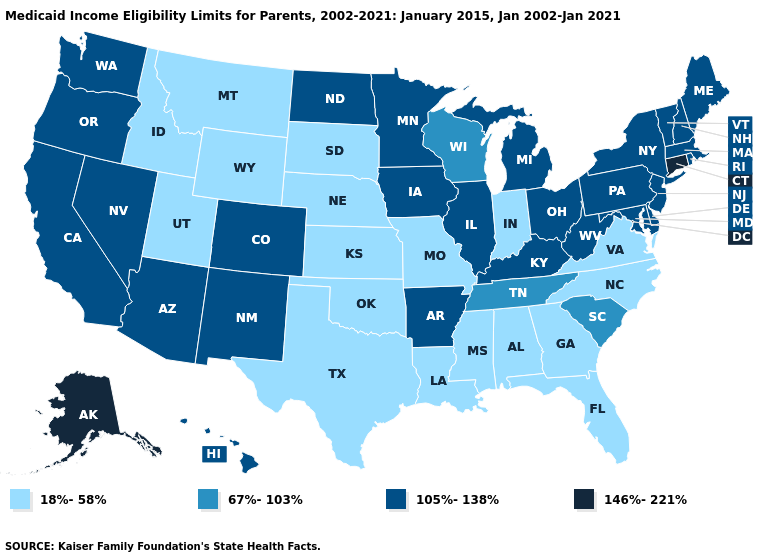Is the legend a continuous bar?
Give a very brief answer. No. Which states have the highest value in the USA?
Keep it brief. Alaska, Connecticut. Name the states that have a value in the range 146%-221%?
Be succinct. Alaska, Connecticut. Name the states that have a value in the range 18%-58%?
Write a very short answer. Alabama, Florida, Georgia, Idaho, Indiana, Kansas, Louisiana, Mississippi, Missouri, Montana, Nebraska, North Carolina, Oklahoma, South Dakota, Texas, Utah, Virginia, Wyoming. What is the value of New Hampshire?
Short answer required. 105%-138%. Name the states that have a value in the range 146%-221%?
Concise answer only. Alaska, Connecticut. Does Alaska have the highest value in the West?
Be succinct. Yes. What is the lowest value in the USA?
Write a very short answer. 18%-58%. What is the value of Missouri?
Concise answer only. 18%-58%. Does North Carolina have a higher value than New Mexico?
Write a very short answer. No. Does Connecticut have the highest value in the Northeast?
Concise answer only. Yes. Which states hav the highest value in the MidWest?
Concise answer only. Illinois, Iowa, Michigan, Minnesota, North Dakota, Ohio. Which states have the lowest value in the USA?
Keep it brief. Alabama, Florida, Georgia, Idaho, Indiana, Kansas, Louisiana, Mississippi, Missouri, Montana, Nebraska, North Carolina, Oklahoma, South Dakota, Texas, Utah, Virginia, Wyoming. What is the value of Montana?
Short answer required. 18%-58%. How many symbols are there in the legend?
Keep it brief. 4. 